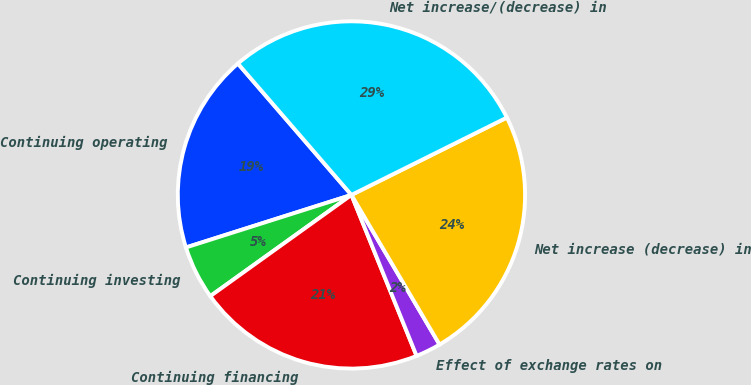<chart> <loc_0><loc_0><loc_500><loc_500><pie_chart><fcel>Continuing operating<fcel>Continuing investing<fcel>Continuing financing<fcel>Effect of exchange rates on<fcel>Net increase (decrease) in<fcel>Net increase/(decrease) in<nl><fcel>18.55%<fcel>5.01%<fcel>21.22%<fcel>2.35%<fcel>23.88%<fcel>28.99%<nl></chart> 